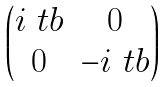<formula> <loc_0><loc_0><loc_500><loc_500>\begin{pmatrix} i \ t b & 0 \\ 0 & - i \ t b \end{pmatrix}</formula> 